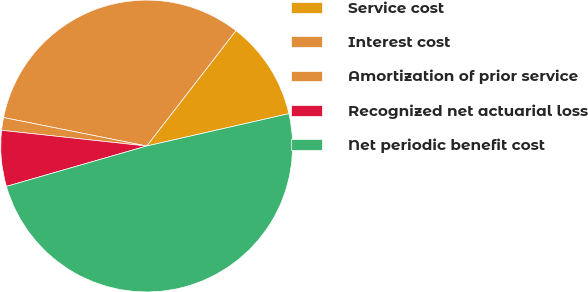Convert chart to OTSL. <chart><loc_0><loc_0><loc_500><loc_500><pie_chart><fcel>Service cost<fcel>Interest cost<fcel>Amortization of prior service<fcel>Recognized net actuarial loss<fcel>Net periodic benefit cost<nl><fcel>10.96%<fcel>32.35%<fcel>1.41%<fcel>6.18%<fcel>49.1%<nl></chart> 